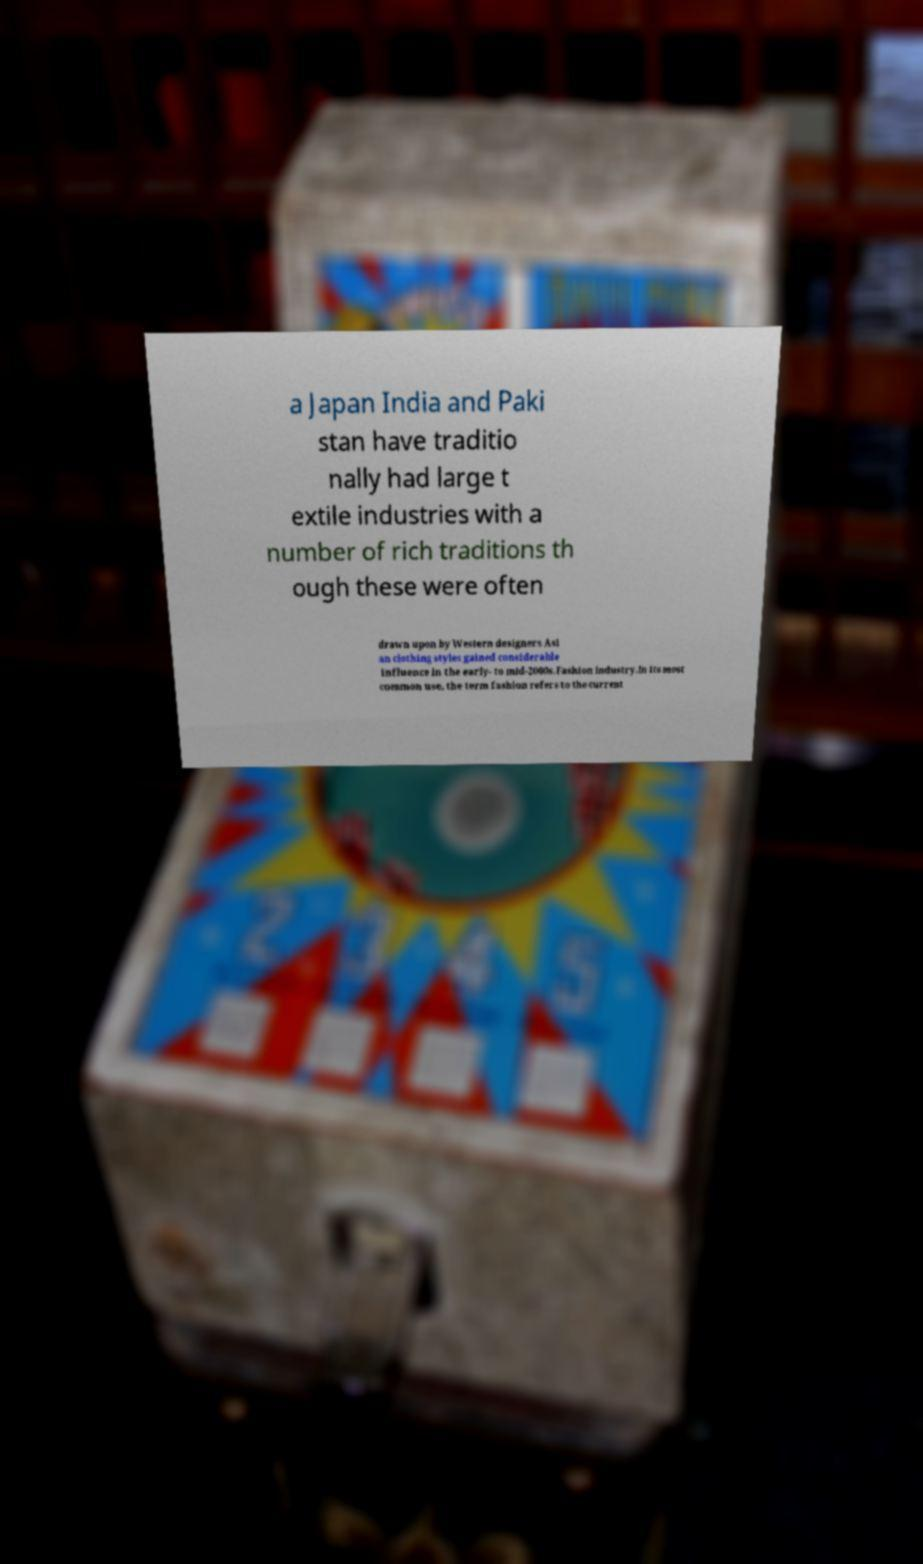Could you extract and type out the text from this image? a Japan India and Paki stan have traditio nally had large t extile industries with a number of rich traditions th ough these were often drawn upon by Western designers Asi an clothing styles gained considerable influence in the early- to mid-2000s.Fashion industry.In its most common use, the term fashion refers to the current 